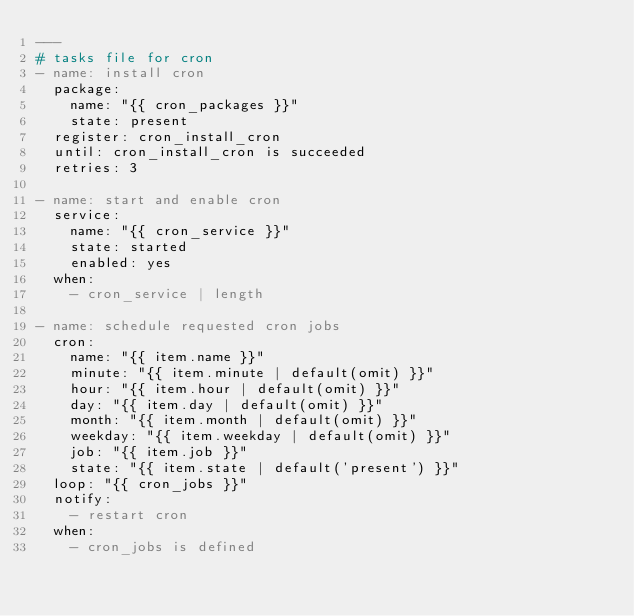Convert code to text. <code><loc_0><loc_0><loc_500><loc_500><_YAML_>---
# tasks file for cron
- name: install cron
  package:
    name: "{{ cron_packages }}"
    state: present
  register: cron_install_cron
  until: cron_install_cron is succeeded
  retries: 3

- name: start and enable cron
  service:
    name: "{{ cron_service }}"
    state: started
    enabled: yes
  when:
    - cron_service | length

- name: schedule requested cron jobs
  cron:
    name: "{{ item.name }}"
    minute: "{{ item.minute | default(omit) }}"
    hour: "{{ item.hour | default(omit) }}"
    day: "{{ item.day | default(omit) }}"
    month: "{{ item.month | default(omit) }}"
    weekday: "{{ item.weekday | default(omit) }}"
    job: "{{ item.job }}"
    state: "{{ item.state | default('present') }}"
  loop: "{{ cron_jobs }}"
  notify:
    - restart cron
  when:
    - cron_jobs is defined
</code> 